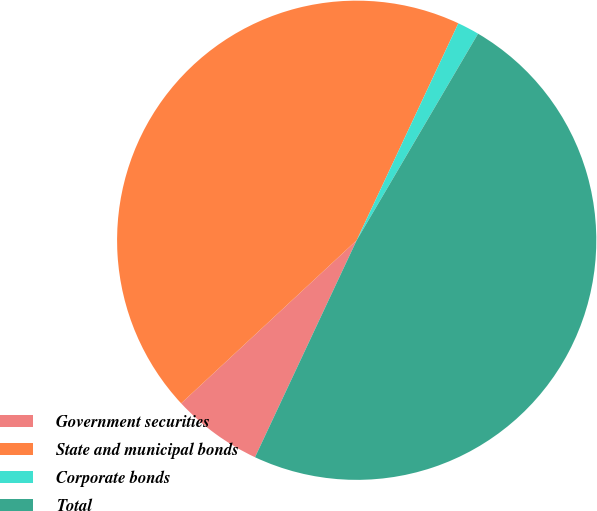<chart> <loc_0><loc_0><loc_500><loc_500><pie_chart><fcel>Government securities<fcel>State and municipal bonds<fcel>Corporate bonds<fcel>Total<nl><fcel>6.11%<fcel>43.89%<fcel>1.48%<fcel>48.52%<nl></chart> 